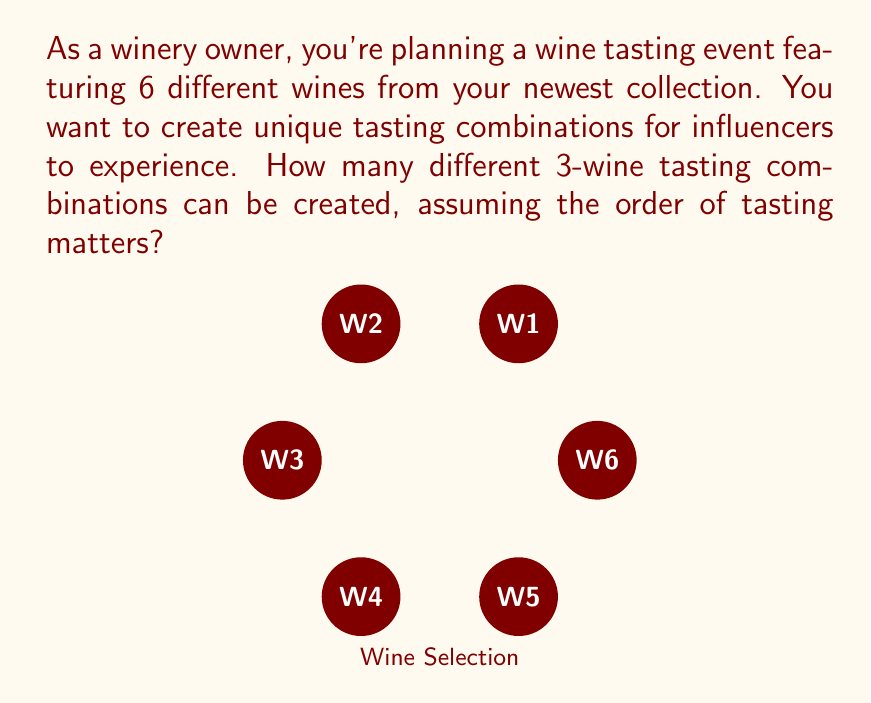Help me with this question. Let's approach this step-by-step using permutation principles:

1) We are selecting 3 wines out of 6, where the order matters. This is a permutation problem.

2) The formula for permutations is:
   $$P(n,r) = \frac{n!}{(n-r)!}$$
   where $n$ is the total number of items to choose from, and $r$ is the number of items being chosen.

3) In this case, $n = 6$ (total wines) and $r = 3$ (wines in each tasting).

4) Plugging into the formula:
   $$P(6,3) = \frac{6!}{(6-3)!} = \frac{6!}{3!}$$

5) Expand this:
   $$\frac{6 \times 5 \times 4 \times 3!}{3!}$$

6) The $3!$ cancels out in the numerator and denominator:
   $$6 \times 5 \times 4 = 120$$

Therefore, there are 120 different 3-wine tasting combinations possible.
Answer: 120 